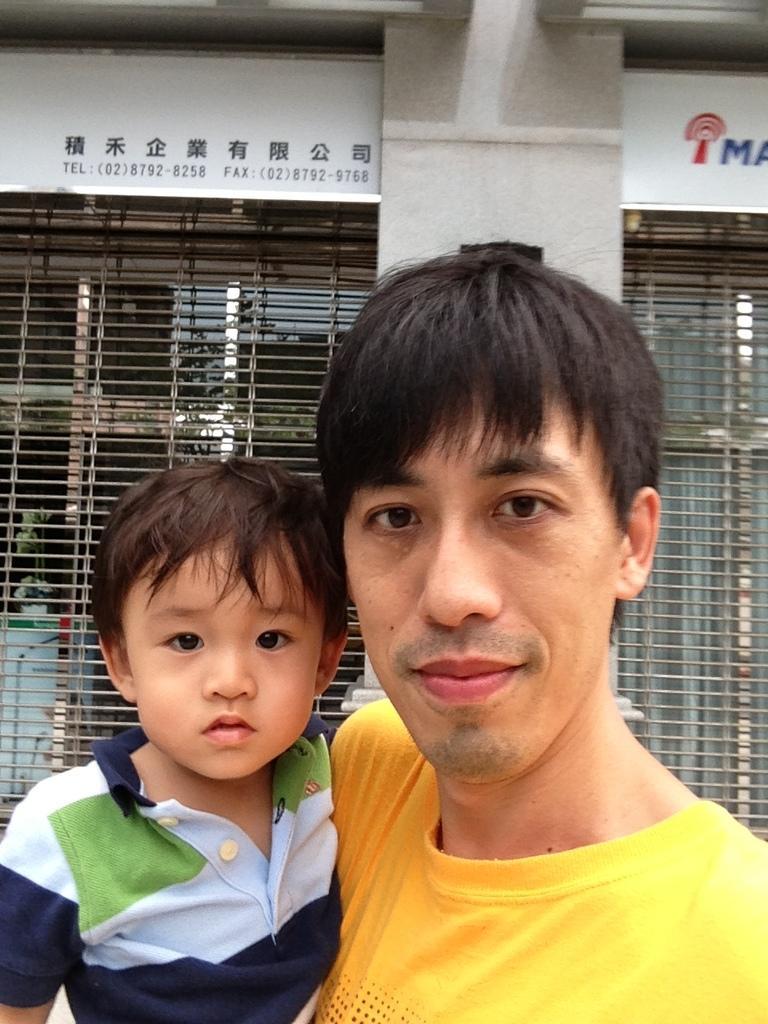How would you summarize this image in a sentence or two? In this image we can see man and kid. In the background we can see pillar, windows. 